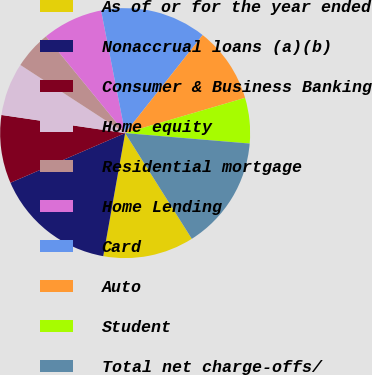Convert chart to OTSL. <chart><loc_0><loc_0><loc_500><loc_500><pie_chart><fcel>As of or for the year ended<fcel>Nonaccrual loans (a)(b)<fcel>Consumer & Business Banking<fcel>Home equity<fcel>Residential mortgage<fcel>Home Lending<fcel>Card<fcel>Auto<fcel>Student<fcel>Total net charge-offs/<nl><fcel>11.76%<fcel>15.69%<fcel>8.82%<fcel>6.86%<fcel>4.9%<fcel>7.84%<fcel>13.73%<fcel>9.8%<fcel>5.88%<fcel>14.71%<nl></chart> 